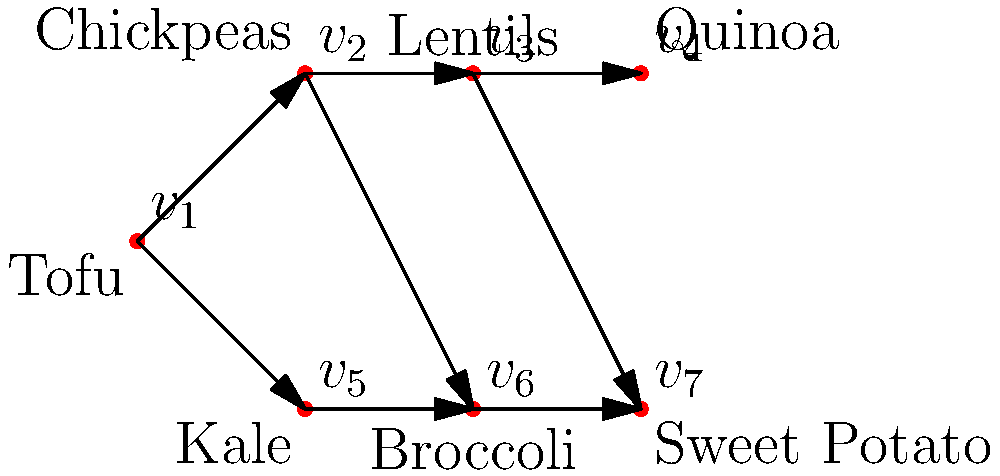You're planning a week of vegan meal prep for your family, including your toddler. The directed acyclic graph above represents the dependencies between different ingredients in your meal plan. Each vertex represents an ingredient, and each edge indicates that the ingredient at the tail of the edge should be prepared before the ingredient at the head. What is the minimum number of days needed to prepare all the ingredients, assuming you can prepare any number of independent ingredients on the same day? To solve this problem, we need to find the longest path in the directed acyclic graph (DAG), also known as the critical path. This will give us the minimum number of days needed to prepare all ingredients while respecting their dependencies.

Let's approach this step-by-step:

1) First, we assign levels to each vertex based on its position in the graph:

   $v_1$ (Tofu): Level 0
   $v_2$ (Chickpeas), $v_5$ (Kale): Level 1
   $v_3$ (Lentils), $v_6$ (Broccoli): Level 2
   $v_4$ (Quinoa), $v_7$ (Sweet Potato): Level 3

2) The number of levels in the graph is 4 (0 to 3).

3) Each level represents a day in our meal prep schedule:
   - Day 1: Prepare Tofu
   - Day 2: Prepare Chickpeas and Kale
   - Day 3: Prepare Lentils and Broccoli
   - Day 4: Prepare Quinoa and Sweet Potato

4) The longest path in this graph is:
   Tofu -> Chickpeas -> Lentils -> Quinoa
   OR
   Tofu -> Chickpeas -> Lentils -> Sweet Potato

   Both of these paths have a length of 4, which corresponds to the number of levels.

5) Therefore, the minimum number of days needed to prepare all ingredients is 4.

This schedule ensures that all dependencies are respected (e.g., Chickpeas are prepared before Lentils, Kale before Broccoli) while minimizing the total preparation time.
Answer: 4 days 